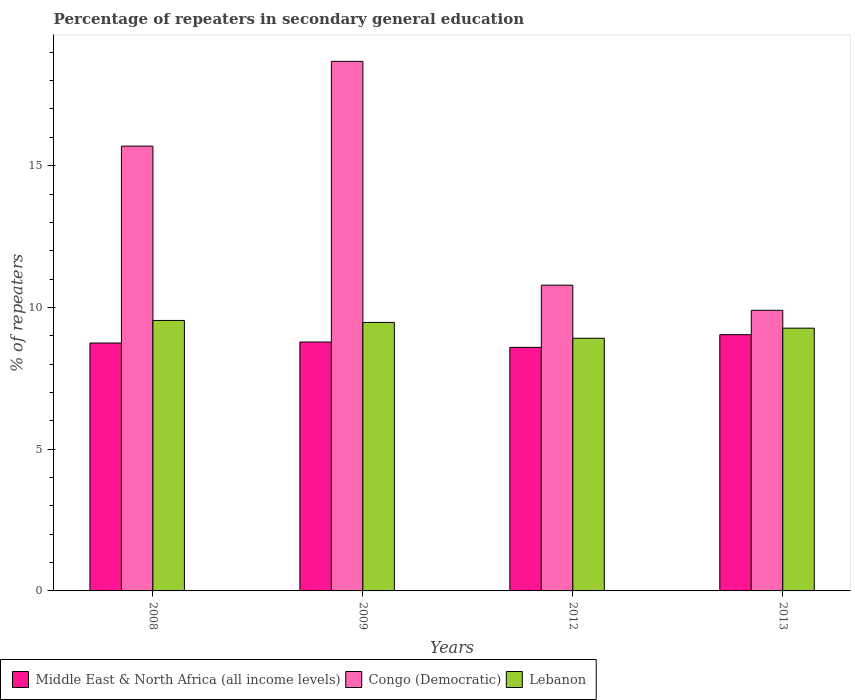How many groups of bars are there?
Ensure brevity in your answer.  4. Are the number of bars per tick equal to the number of legend labels?
Make the answer very short. Yes. Are the number of bars on each tick of the X-axis equal?
Offer a very short reply. Yes. What is the percentage of repeaters in secondary general education in Lebanon in 2013?
Ensure brevity in your answer.  9.27. Across all years, what is the maximum percentage of repeaters in secondary general education in Middle East & North Africa (all income levels)?
Make the answer very short. 9.04. Across all years, what is the minimum percentage of repeaters in secondary general education in Lebanon?
Provide a short and direct response. 8.91. In which year was the percentage of repeaters in secondary general education in Lebanon maximum?
Your answer should be very brief. 2008. In which year was the percentage of repeaters in secondary general education in Lebanon minimum?
Offer a terse response. 2012. What is the total percentage of repeaters in secondary general education in Middle East & North Africa (all income levels) in the graph?
Offer a very short reply. 35.15. What is the difference between the percentage of repeaters in secondary general education in Lebanon in 2009 and that in 2013?
Your response must be concise. 0.2. What is the difference between the percentage of repeaters in secondary general education in Middle East & North Africa (all income levels) in 2009 and the percentage of repeaters in secondary general education in Lebanon in 2012?
Your answer should be compact. -0.13. What is the average percentage of repeaters in secondary general education in Middle East & North Africa (all income levels) per year?
Make the answer very short. 8.79. In the year 2009, what is the difference between the percentage of repeaters in secondary general education in Middle East & North Africa (all income levels) and percentage of repeaters in secondary general education in Congo (Democratic)?
Your answer should be very brief. -9.9. What is the ratio of the percentage of repeaters in secondary general education in Middle East & North Africa (all income levels) in 2008 to that in 2012?
Offer a very short reply. 1.02. Is the percentage of repeaters in secondary general education in Congo (Democratic) in 2009 less than that in 2013?
Your answer should be compact. No. What is the difference between the highest and the second highest percentage of repeaters in secondary general education in Middle East & North Africa (all income levels)?
Ensure brevity in your answer.  0.26. What is the difference between the highest and the lowest percentage of repeaters in secondary general education in Middle East & North Africa (all income levels)?
Give a very brief answer. 0.45. What does the 1st bar from the left in 2012 represents?
Make the answer very short. Middle East & North Africa (all income levels). What does the 3rd bar from the right in 2008 represents?
Keep it short and to the point. Middle East & North Africa (all income levels). How many bars are there?
Your answer should be compact. 12. Are all the bars in the graph horizontal?
Your answer should be compact. No. How many years are there in the graph?
Make the answer very short. 4. What is the difference between two consecutive major ticks on the Y-axis?
Provide a succinct answer. 5. Does the graph contain grids?
Your answer should be very brief. No. How many legend labels are there?
Give a very brief answer. 3. What is the title of the graph?
Your answer should be very brief. Percentage of repeaters in secondary general education. Does "Tanzania" appear as one of the legend labels in the graph?
Offer a very short reply. No. What is the label or title of the X-axis?
Provide a short and direct response. Years. What is the label or title of the Y-axis?
Keep it short and to the point. % of repeaters. What is the % of repeaters of Middle East & North Africa (all income levels) in 2008?
Your response must be concise. 8.74. What is the % of repeaters of Congo (Democratic) in 2008?
Ensure brevity in your answer.  15.69. What is the % of repeaters in Lebanon in 2008?
Ensure brevity in your answer.  9.54. What is the % of repeaters in Middle East & North Africa (all income levels) in 2009?
Your response must be concise. 8.78. What is the % of repeaters in Congo (Democratic) in 2009?
Make the answer very short. 18.68. What is the % of repeaters in Lebanon in 2009?
Offer a terse response. 9.47. What is the % of repeaters in Middle East & North Africa (all income levels) in 2012?
Your response must be concise. 8.59. What is the % of repeaters in Congo (Democratic) in 2012?
Provide a short and direct response. 10.79. What is the % of repeaters of Lebanon in 2012?
Your response must be concise. 8.91. What is the % of repeaters of Middle East & North Africa (all income levels) in 2013?
Keep it short and to the point. 9.04. What is the % of repeaters in Congo (Democratic) in 2013?
Your answer should be very brief. 9.9. What is the % of repeaters of Lebanon in 2013?
Give a very brief answer. 9.27. Across all years, what is the maximum % of repeaters in Middle East & North Africa (all income levels)?
Provide a succinct answer. 9.04. Across all years, what is the maximum % of repeaters in Congo (Democratic)?
Your answer should be very brief. 18.68. Across all years, what is the maximum % of repeaters in Lebanon?
Your answer should be very brief. 9.54. Across all years, what is the minimum % of repeaters of Middle East & North Africa (all income levels)?
Give a very brief answer. 8.59. Across all years, what is the minimum % of repeaters in Congo (Democratic)?
Make the answer very short. 9.9. Across all years, what is the minimum % of repeaters of Lebanon?
Your response must be concise. 8.91. What is the total % of repeaters in Middle East & North Africa (all income levels) in the graph?
Your answer should be compact. 35.15. What is the total % of repeaters of Congo (Democratic) in the graph?
Give a very brief answer. 55.05. What is the total % of repeaters of Lebanon in the graph?
Give a very brief answer. 37.19. What is the difference between the % of repeaters in Middle East & North Africa (all income levels) in 2008 and that in 2009?
Your answer should be compact. -0.04. What is the difference between the % of repeaters in Congo (Democratic) in 2008 and that in 2009?
Your response must be concise. -2.99. What is the difference between the % of repeaters in Lebanon in 2008 and that in 2009?
Your response must be concise. 0.07. What is the difference between the % of repeaters of Middle East & North Africa (all income levels) in 2008 and that in 2012?
Ensure brevity in your answer.  0.15. What is the difference between the % of repeaters of Congo (Democratic) in 2008 and that in 2012?
Your answer should be compact. 4.9. What is the difference between the % of repeaters in Lebanon in 2008 and that in 2012?
Keep it short and to the point. 0.63. What is the difference between the % of repeaters of Middle East & North Africa (all income levels) in 2008 and that in 2013?
Give a very brief answer. -0.29. What is the difference between the % of repeaters in Congo (Democratic) in 2008 and that in 2013?
Provide a short and direct response. 5.79. What is the difference between the % of repeaters in Lebanon in 2008 and that in 2013?
Offer a very short reply. 0.27. What is the difference between the % of repeaters in Middle East & North Africa (all income levels) in 2009 and that in 2012?
Keep it short and to the point. 0.19. What is the difference between the % of repeaters of Congo (Democratic) in 2009 and that in 2012?
Give a very brief answer. 7.9. What is the difference between the % of repeaters in Lebanon in 2009 and that in 2012?
Make the answer very short. 0.56. What is the difference between the % of repeaters of Middle East & North Africa (all income levels) in 2009 and that in 2013?
Offer a terse response. -0.26. What is the difference between the % of repeaters in Congo (Democratic) in 2009 and that in 2013?
Provide a succinct answer. 8.78. What is the difference between the % of repeaters of Lebanon in 2009 and that in 2013?
Provide a succinct answer. 0.2. What is the difference between the % of repeaters in Middle East & North Africa (all income levels) in 2012 and that in 2013?
Your response must be concise. -0.45. What is the difference between the % of repeaters of Congo (Democratic) in 2012 and that in 2013?
Keep it short and to the point. 0.89. What is the difference between the % of repeaters in Lebanon in 2012 and that in 2013?
Give a very brief answer. -0.35. What is the difference between the % of repeaters in Middle East & North Africa (all income levels) in 2008 and the % of repeaters in Congo (Democratic) in 2009?
Keep it short and to the point. -9.94. What is the difference between the % of repeaters of Middle East & North Africa (all income levels) in 2008 and the % of repeaters of Lebanon in 2009?
Provide a succinct answer. -0.73. What is the difference between the % of repeaters of Congo (Democratic) in 2008 and the % of repeaters of Lebanon in 2009?
Provide a short and direct response. 6.22. What is the difference between the % of repeaters in Middle East & North Africa (all income levels) in 2008 and the % of repeaters in Congo (Democratic) in 2012?
Keep it short and to the point. -2.04. What is the difference between the % of repeaters of Middle East & North Africa (all income levels) in 2008 and the % of repeaters of Lebanon in 2012?
Provide a succinct answer. -0.17. What is the difference between the % of repeaters in Congo (Democratic) in 2008 and the % of repeaters in Lebanon in 2012?
Your answer should be very brief. 6.78. What is the difference between the % of repeaters of Middle East & North Africa (all income levels) in 2008 and the % of repeaters of Congo (Democratic) in 2013?
Keep it short and to the point. -1.15. What is the difference between the % of repeaters of Middle East & North Africa (all income levels) in 2008 and the % of repeaters of Lebanon in 2013?
Your answer should be compact. -0.52. What is the difference between the % of repeaters of Congo (Democratic) in 2008 and the % of repeaters of Lebanon in 2013?
Make the answer very short. 6.42. What is the difference between the % of repeaters in Middle East & North Africa (all income levels) in 2009 and the % of repeaters in Congo (Democratic) in 2012?
Your answer should be compact. -2.01. What is the difference between the % of repeaters in Middle East & North Africa (all income levels) in 2009 and the % of repeaters in Lebanon in 2012?
Offer a very short reply. -0.13. What is the difference between the % of repeaters of Congo (Democratic) in 2009 and the % of repeaters of Lebanon in 2012?
Make the answer very short. 9.77. What is the difference between the % of repeaters in Middle East & North Africa (all income levels) in 2009 and the % of repeaters in Congo (Democratic) in 2013?
Your response must be concise. -1.12. What is the difference between the % of repeaters of Middle East & North Africa (all income levels) in 2009 and the % of repeaters of Lebanon in 2013?
Provide a short and direct response. -0.49. What is the difference between the % of repeaters in Congo (Democratic) in 2009 and the % of repeaters in Lebanon in 2013?
Offer a very short reply. 9.41. What is the difference between the % of repeaters of Middle East & North Africa (all income levels) in 2012 and the % of repeaters of Congo (Democratic) in 2013?
Ensure brevity in your answer.  -1.31. What is the difference between the % of repeaters in Middle East & North Africa (all income levels) in 2012 and the % of repeaters in Lebanon in 2013?
Ensure brevity in your answer.  -0.68. What is the difference between the % of repeaters of Congo (Democratic) in 2012 and the % of repeaters of Lebanon in 2013?
Your answer should be compact. 1.52. What is the average % of repeaters of Middle East & North Africa (all income levels) per year?
Provide a succinct answer. 8.79. What is the average % of repeaters of Congo (Democratic) per year?
Give a very brief answer. 13.76. What is the average % of repeaters of Lebanon per year?
Your answer should be compact. 9.3. In the year 2008, what is the difference between the % of repeaters in Middle East & North Africa (all income levels) and % of repeaters in Congo (Democratic)?
Your answer should be very brief. -6.95. In the year 2008, what is the difference between the % of repeaters in Middle East & North Africa (all income levels) and % of repeaters in Lebanon?
Provide a short and direct response. -0.8. In the year 2008, what is the difference between the % of repeaters in Congo (Democratic) and % of repeaters in Lebanon?
Ensure brevity in your answer.  6.15. In the year 2009, what is the difference between the % of repeaters in Middle East & North Africa (all income levels) and % of repeaters in Congo (Democratic)?
Your answer should be compact. -9.9. In the year 2009, what is the difference between the % of repeaters in Middle East & North Africa (all income levels) and % of repeaters in Lebanon?
Offer a terse response. -0.69. In the year 2009, what is the difference between the % of repeaters in Congo (Democratic) and % of repeaters in Lebanon?
Your answer should be very brief. 9.21. In the year 2012, what is the difference between the % of repeaters of Middle East & North Africa (all income levels) and % of repeaters of Congo (Democratic)?
Provide a succinct answer. -2.19. In the year 2012, what is the difference between the % of repeaters in Middle East & North Africa (all income levels) and % of repeaters in Lebanon?
Your answer should be compact. -0.32. In the year 2012, what is the difference between the % of repeaters of Congo (Democratic) and % of repeaters of Lebanon?
Your response must be concise. 1.87. In the year 2013, what is the difference between the % of repeaters of Middle East & North Africa (all income levels) and % of repeaters of Congo (Democratic)?
Your answer should be compact. -0.86. In the year 2013, what is the difference between the % of repeaters of Middle East & North Africa (all income levels) and % of repeaters of Lebanon?
Keep it short and to the point. -0.23. In the year 2013, what is the difference between the % of repeaters of Congo (Democratic) and % of repeaters of Lebanon?
Your answer should be compact. 0.63. What is the ratio of the % of repeaters in Congo (Democratic) in 2008 to that in 2009?
Give a very brief answer. 0.84. What is the ratio of the % of repeaters in Lebanon in 2008 to that in 2009?
Your answer should be very brief. 1.01. What is the ratio of the % of repeaters in Middle East & North Africa (all income levels) in 2008 to that in 2012?
Make the answer very short. 1.02. What is the ratio of the % of repeaters of Congo (Democratic) in 2008 to that in 2012?
Offer a very short reply. 1.45. What is the ratio of the % of repeaters in Lebanon in 2008 to that in 2012?
Offer a terse response. 1.07. What is the ratio of the % of repeaters of Middle East & North Africa (all income levels) in 2008 to that in 2013?
Make the answer very short. 0.97. What is the ratio of the % of repeaters of Congo (Democratic) in 2008 to that in 2013?
Offer a terse response. 1.58. What is the ratio of the % of repeaters in Lebanon in 2008 to that in 2013?
Offer a very short reply. 1.03. What is the ratio of the % of repeaters in Middle East & North Africa (all income levels) in 2009 to that in 2012?
Keep it short and to the point. 1.02. What is the ratio of the % of repeaters of Congo (Democratic) in 2009 to that in 2012?
Offer a terse response. 1.73. What is the ratio of the % of repeaters in Lebanon in 2009 to that in 2012?
Provide a short and direct response. 1.06. What is the ratio of the % of repeaters of Middle East & North Africa (all income levels) in 2009 to that in 2013?
Your answer should be very brief. 0.97. What is the ratio of the % of repeaters in Congo (Democratic) in 2009 to that in 2013?
Keep it short and to the point. 1.89. What is the ratio of the % of repeaters in Lebanon in 2009 to that in 2013?
Your answer should be very brief. 1.02. What is the ratio of the % of repeaters in Middle East & North Africa (all income levels) in 2012 to that in 2013?
Ensure brevity in your answer.  0.95. What is the ratio of the % of repeaters in Congo (Democratic) in 2012 to that in 2013?
Your answer should be compact. 1.09. What is the ratio of the % of repeaters of Lebanon in 2012 to that in 2013?
Keep it short and to the point. 0.96. What is the difference between the highest and the second highest % of repeaters of Middle East & North Africa (all income levels)?
Keep it short and to the point. 0.26. What is the difference between the highest and the second highest % of repeaters of Congo (Democratic)?
Offer a very short reply. 2.99. What is the difference between the highest and the second highest % of repeaters in Lebanon?
Make the answer very short. 0.07. What is the difference between the highest and the lowest % of repeaters of Middle East & North Africa (all income levels)?
Your answer should be very brief. 0.45. What is the difference between the highest and the lowest % of repeaters of Congo (Democratic)?
Your answer should be very brief. 8.78. What is the difference between the highest and the lowest % of repeaters in Lebanon?
Provide a succinct answer. 0.63. 